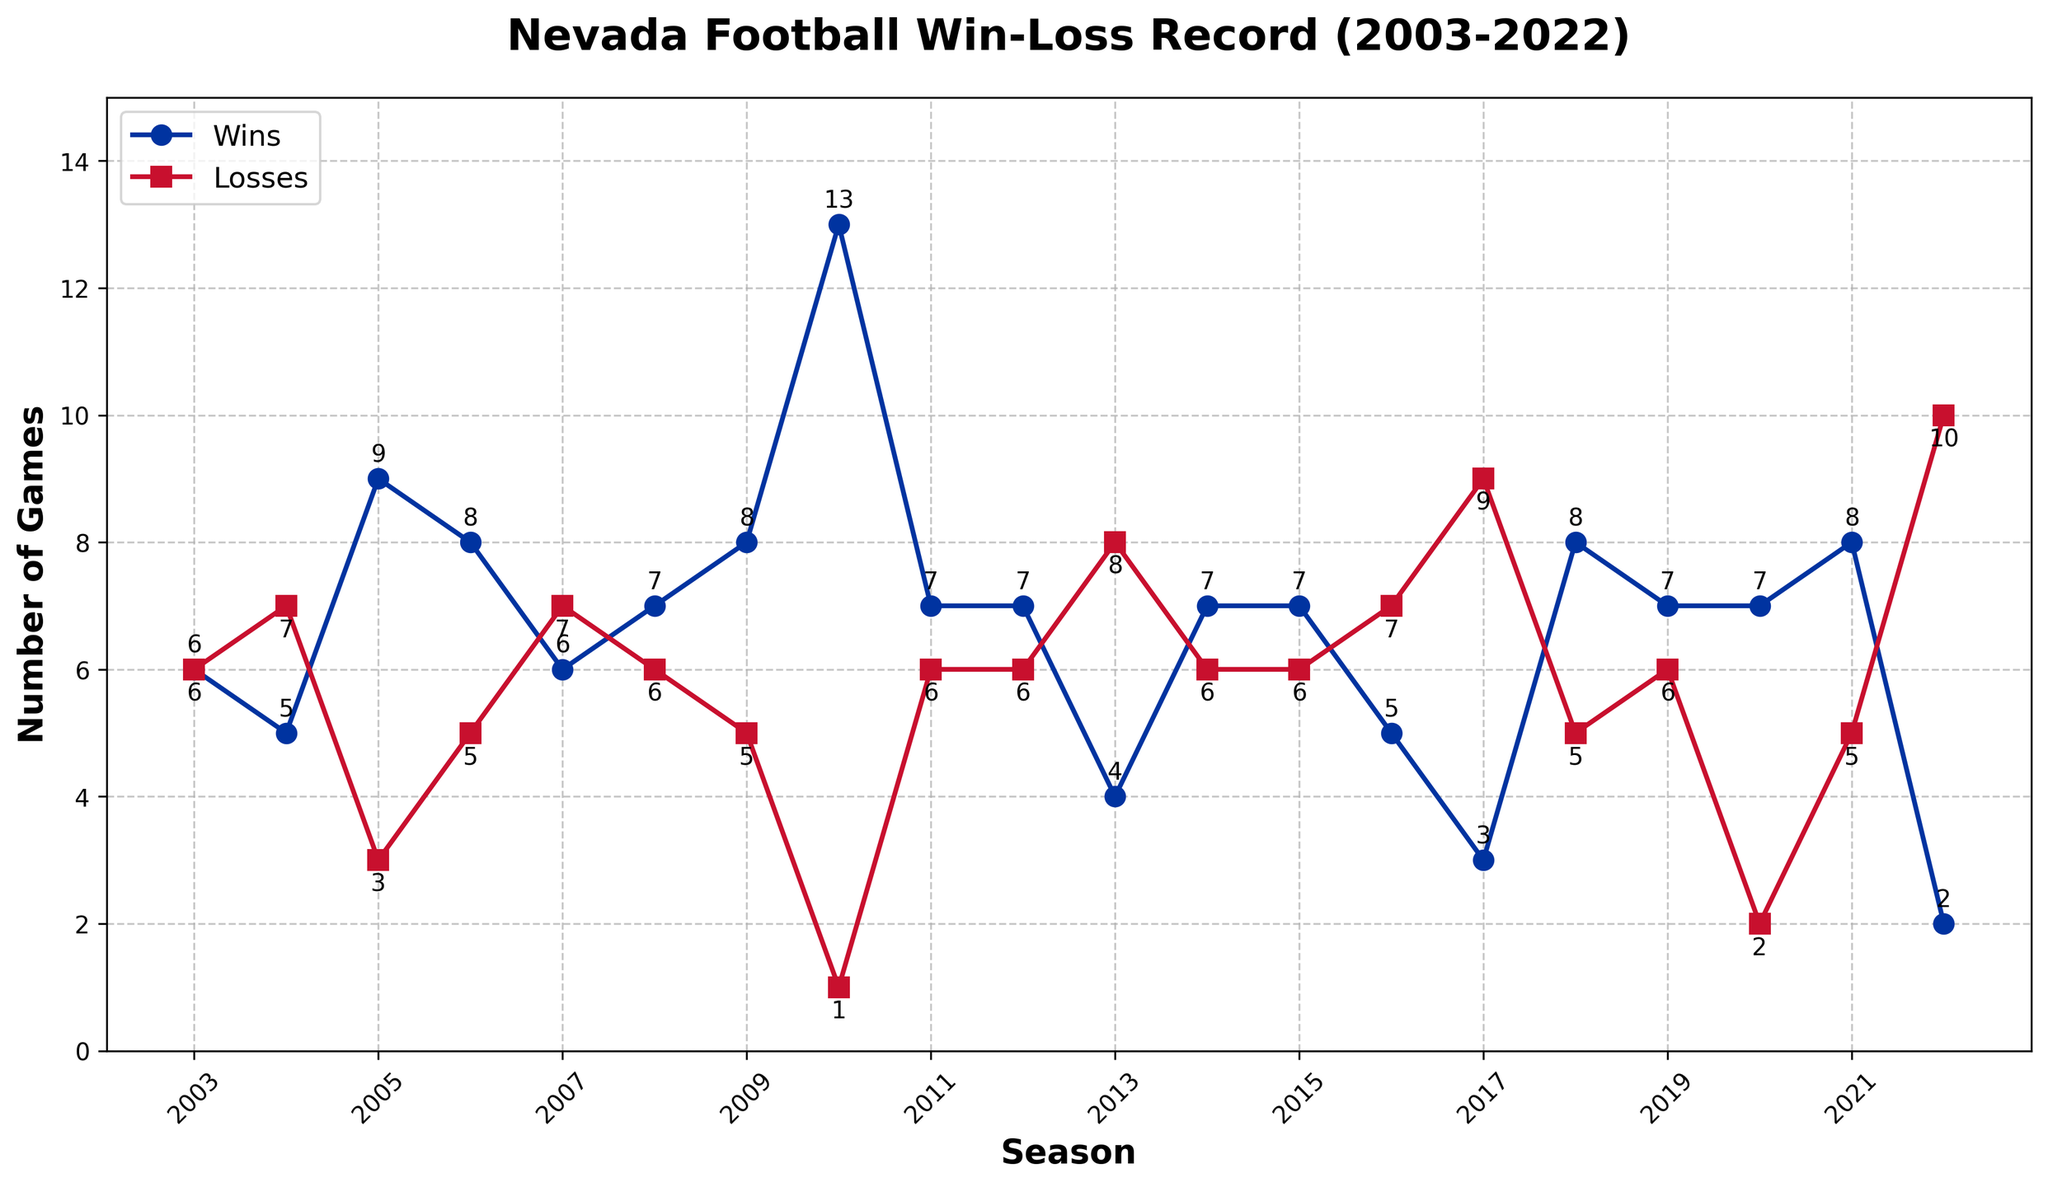How many wins did Nevada have in the 2010 season, and how does it compare to their losses in the same season? To find the wins and losses for the Nevada football team in the 2010 season, locate the data point on the plot for 2010. The plot shows 13 wins and 1 loss. Compare these numbers: 13 wins are significantly higher than 1 loss.
Answer: 13 wins, 1 loss Which season had the highest number of wins for Nevada, and how many wins were there? Look at the line representing the number of wins on the plot and identify the peak point. The highest point is in the 2010 season, where Nevada had 13 wins.
Answer: 2010, 13 wins What is the trend in Nevada's win-loss record from 2003 to 2022? Observe the general direction of both the wins and losses lines over the seasons. The wins fluctuate with notable peaks around 2005 and 2010 and generally decline after that, while losses also fluctuate but have an increasing trend in recent seasons, peaking in 2022.
Answer: Fluctuating wins with a peak in 2010, generally increasing losses peaking in 2022 In how many seasons did Nevada win more than 7 games? Scan the wins line on the plot and count the seasons where the number of wins is greater than 7. These seasons are 2005, 2006, 2009, 2010, 2011, 2018, 2020, and 2021, amounting to 8 seasons.
Answer: 8 seasons Compare the win-loss record for the 2007 and 2022 seasons. Which of these seasons was worse for Nevada in terms of losses? Identify the data points for the 2007 and 2022 seasons on the plot. In 2007, Nevada had 7 losses, while in 2022, they had 10 losses. Since 10 losses are more than 7, the 2022 season was worse in terms of losses.
Answer: 2022 season How many times did Nevada win exactly 7 games in a season? Examine the plot and count the number of seasons where the wins line hits the value of 7. These seasons are 2008, 2011, 2012, 2014, 2015, 2019, and 2020, equating to 7 times.
Answer: 7 times In which seasons did Nevada have an equal number of wins and losses, and what was this number? Look for points on the plot where the wins and losses lines intersect. This occurs only in the 2003 season, where both wins and losses are 6.
Answer: 2003 season, 6 wins and 6 losses What was the overall difference in the number of wins and losses over the entire period from 2003 to 2022? To calculate this, sum all wins and losses across all seasons and find the difference. Summing the wins (6+5+9+8+6+7+8+13+7+7+4+7+7+5+3+8+7+7+8+2 = 136) and the losses (6+7+3+5+7+6+5+1+6+6+8+6+6+7+9+5+6+2+5+10 = 110), the difference is 136 - 110 = 26.
Answer: 26 